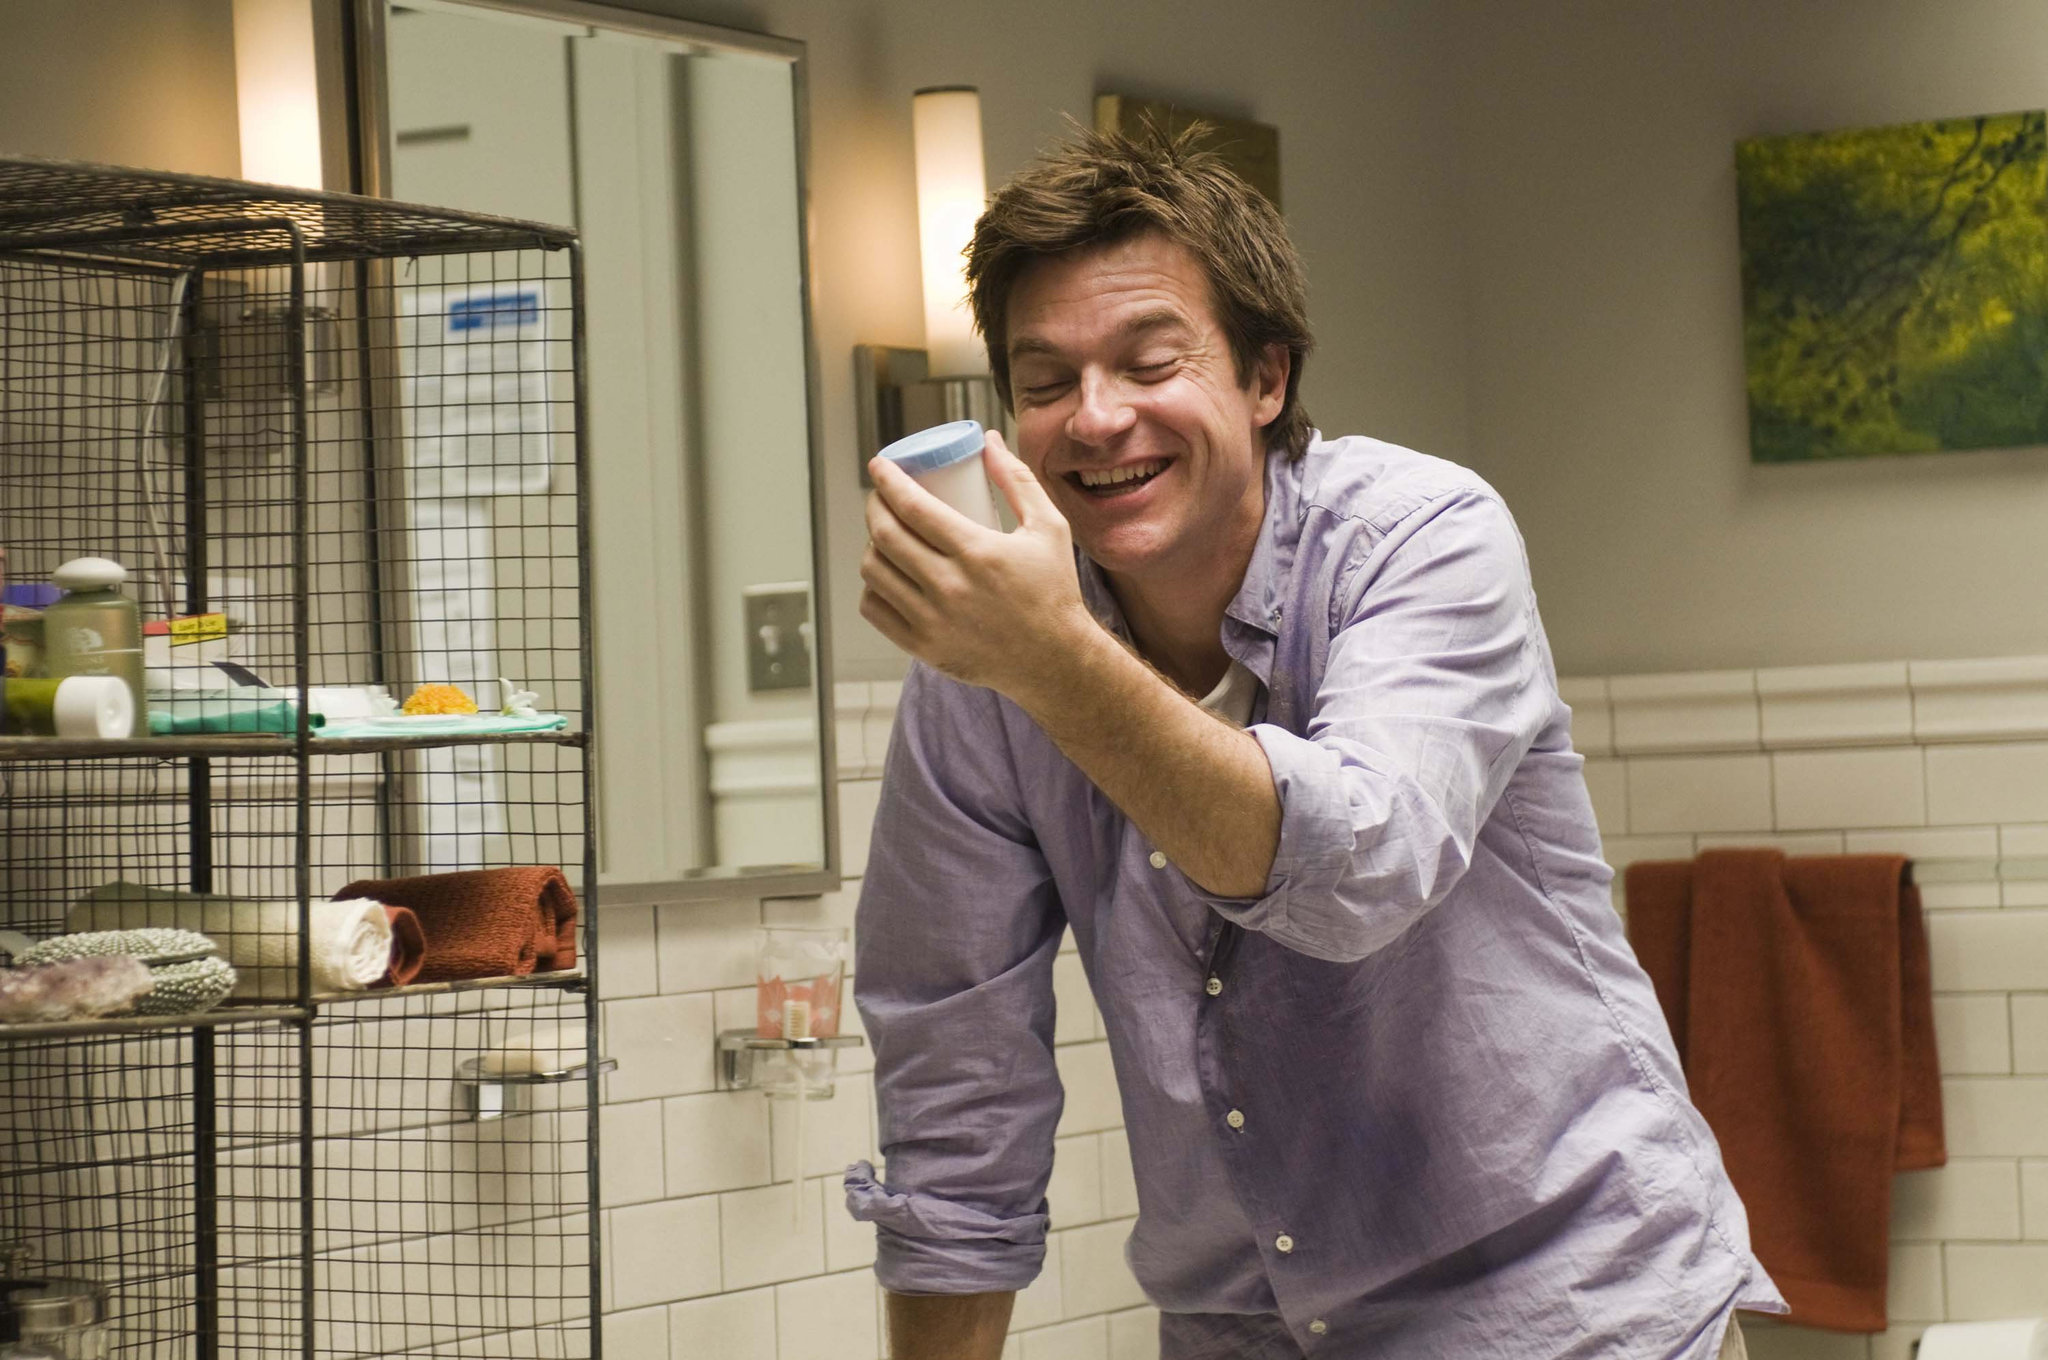Please describe the scene in an extremely detailed and imaginative way. In this vibrant and spirited scene, a man stands amid the serene chaos of his eclectic bathroom sanctuary. His laughter fills the room, a contagious and delightful sound as he holds a sky-blue cup to his cheek, perhaps filling it with the echo of a joyful anecdote. He is casually clad in a lavender button-down shirt, with sleeves rolled up, suggesting a relaxed and spontaneous moment. The bathroom, a mosaic of personal touches, features a white ceramic sink standing against a backdrop of glossy white subway tiles, reminiscent of a classic New York subway station, stark and clean. Adjacent to the sink, a black metal shelf houses an array of toiletries - a harmonious clutter of essentials, each telling its own tale of daily rituals. A russet-colored towel is nonchalantly draped on a bar below, hinting at the man's practicality. However, the pièce de résistance of this scene is a birdcage that houses a chirpy yellow bird - an unlikely bathroom companion who brings a streak of nature's chaos into this tiled haven. The walls are adorned with a picturesque painting of a lush tree, offering an illusion of the outdoors within these confined ceramic quarters. Warm, gentle lighting envelopes the entire setting, casting an inviting glow that makes this ordinary bathroom moment feel extraordinarily intimate and human. 